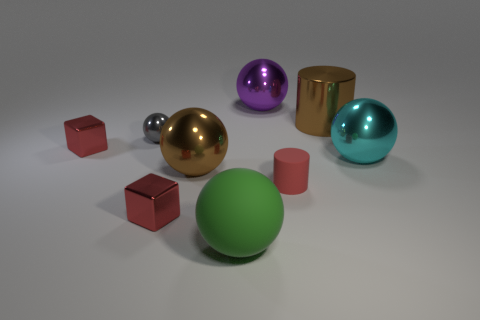What is the size of the red cube that is in front of the large ball right of the large purple metal object?
Your response must be concise. Small. How many metallic things are blue objects or red objects?
Ensure brevity in your answer.  2. How many big cyan metal balls are there?
Ensure brevity in your answer.  1. Do the big brown thing that is to the left of the tiny red cylinder and the cylinder in front of the gray thing have the same material?
Your answer should be very brief. No. There is another large rubber thing that is the same shape as the purple object; what is its color?
Make the answer very short. Green. What material is the cylinder that is in front of the ball that is right of the purple metal object?
Your response must be concise. Rubber. Is the shape of the metal object in front of the red matte object the same as the brown metal thing right of the large brown sphere?
Ensure brevity in your answer.  No. There is a thing that is right of the purple thing and to the left of the big brown cylinder; what is its size?
Keep it short and to the point. Small. How many other things are there of the same color as the tiny sphere?
Give a very brief answer. 0. Is the large brown object to the left of the big purple metal object made of the same material as the brown cylinder?
Your answer should be compact. Yes. 